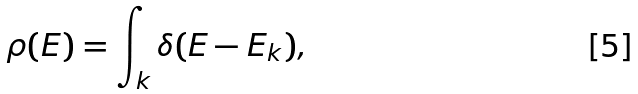Convert formula to latex. <formula><loc_0><loc_0><loc_500><loc_500>\rho ( E ) = \int _ { k } \delta ( E - E _ { k } ) ,</formula> 